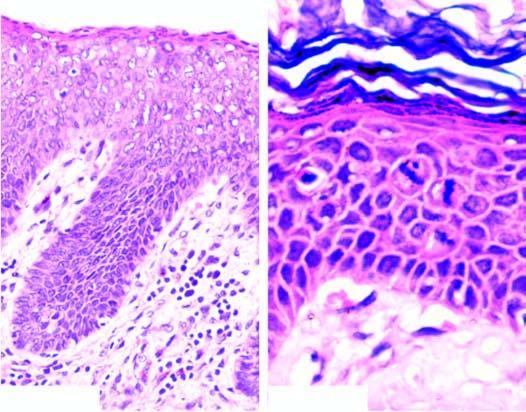s bone biopsy hyperkeratosis, parakeratosis, acanthosis, koilocytosis and presence of atypical anaplastic cells throughout the entire thickness of the epithelium?
Answer the question using a single word or phrase. No 